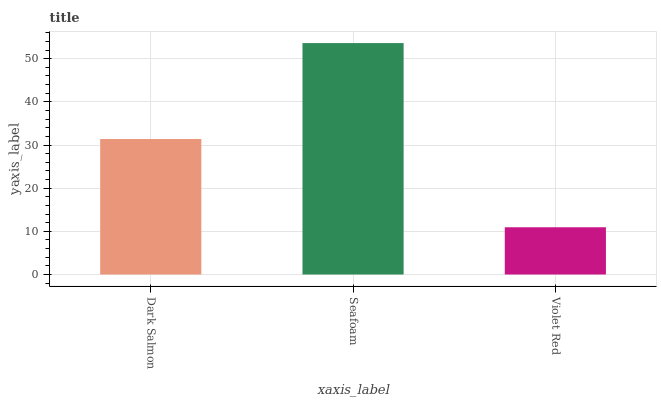Is Violet Red the minimum?
Answer yes or no. Yes. Is Seafoam the maximum?
Answer yes or no. Yes. Is Seafoam the minimum?
Answer yes or no. No. Is Violet Red the maximum?
Answer yes or no. No. Is Seafoam greater than Violet Red?
Answer yes or no. Yes. Is Violet Red less than Seafoam?
Answer yes or no. Yes. Is Violet Red greater than Seafoam?
Answer yes or no. No. Is Seafoam less than Violet Red?
Answer yes or no. No. Is Dark Salmon the high median?
Answer yes or no. Yes. Is Dark Salmon the low median?
Answer yes or no. Yes. Is Seafoam the high median?
Answer yes or no. No. Is Violet Red the low median?
Answer yes or no. No. 